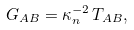Convert formula to latex. <formula><loc_0><loc_0><loc_500><loc_500>G _ { A B } = \kappa _ { n } ^ { - 2 } \, T _ { A B } ,</formula> 